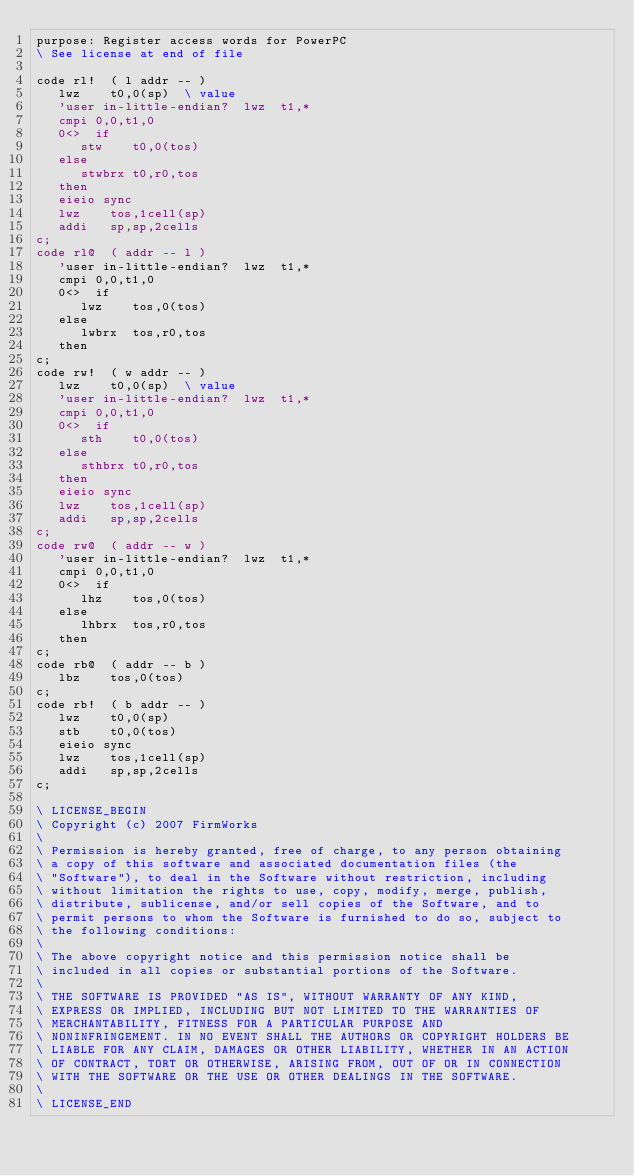<code> <loc_0><loc_0><loc_500><loc_500><_Forth_>purpose: Register access words for PowerPC
\ See license at end of file

code rl!  ( l addr -- )
   lwz    t0,0(sp)	\ value
   'user in-little-endian?  lwz  t1,*
   cmpi 0,0,t1,0
   0<>  if
      stw    t0,0(tos)
   else
      stwbrx t0,r0,tos
   then
   eieio sync
   lwz    tos,1cell(sp)
   addi   sp,sp,2cells
c;
code rl@  ( addr -- l )
   'user in-little-endian?  lwz  t1,*
   cmpi 0,0,t1,0
   0<>  if
      lwz    tos,0(tos)
   else
      lwbrx  tos,r0,tos
   then
c;
code rw!  ( w addr -- )
   lwz    t0,0(sp)	\ value
   'user in-little-endian?  lwz  t1,*
   cmpi 0,0,t1,0
   0<>  if
      sth    t0,0(tos)
   else
      sthbrx t0,r0,tos
   then
   eieio sync
   lwz    tos,1cell(sp)
   addi   sp,sp,2cells
c;
code rw@  ( addr -- w )
   'user in-little-endian?  lwz  t1,*
   cmpi 0,0,t1,0
   0<>  if
      lhz    tos,0(tos)
   else
      lhbrx  tos,r0,tos
   then
c;
code rb@  ( addr -- b )
   lbz    tos,0(tos)
c;
code rb!  ( b addr -- )
   lwz    t0,0(sp)
   stb    t0,0(tos)
   eieio sync
   lwz    tos,1cell(sp)
   addi   sp,sp,2cells
c;

\ LICENSE_BEGIN
\ Copyright (c) 2007 FirmWorks
\ 
\ Permission is hereby granted, free of charge, to any person obtaining
\ a copy of this software and associated documentation files (the
\ "Software"), to deal in the Software without restriction, including
\ without limitation the rights to use, copy, modify, merge, publish,
\ distribute, sublicense, and/or sell copies of the Software, and to
\ permit persons to whom the Software is furnished to do so, subject to
\ the following conditions:
\ 
\ The above copyright notice and this permission notice shall be
\ included in all copies or substantial portions of the Software.
\ 
\ THE SOFTWARE IS PROVIDED "AS IS", WITHOUT WARRANTY OF ANY KIND,
\ EXPRESS OR IMPLIED, INCLUDING BUT NOT LIMITED TO THE WARRANTIES OF
\ MERCHANTABILITY, FITNESS FOR A PARTICULAR PURPOSE AND
\ NONINFRINGEMENT. IN NO EVENT SHALL THE AUTHORS OR COPYRIGHT HOLDERS BE
\ LIABLE FOR ANY CLAIM, DAMAGES OR OTHER LIABILITY, WHETHER IN AN ACTION
\ OF CONTRACT, TORT OR OTHERWISE, ARISING FROM, OUT OF OR IN CONNECTION
\ WITH THE SOFTWARE OR THE USE OR OTHER DEALINGS IN THE SOFTWARE.
\
\ LICENSE_END
</code> 